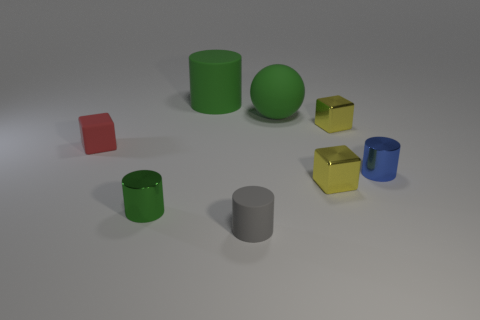Add 2 big cyan cylinders. How many objects exist? 10 Subtract all cubes. How many objects are left? 5 Add 2 tiny yellow shiny objects. How many tiny yellow shiny objects exist? 4 Subtract 0 purple cylinders. How many objects are left? 8 Subtract all large rubber cylinders. Subtract all large green matte balls. How many objects are left? 6 Add 2 tiny gray rubber cylinders. How many tiny gray rubber cylinders are left? 3 